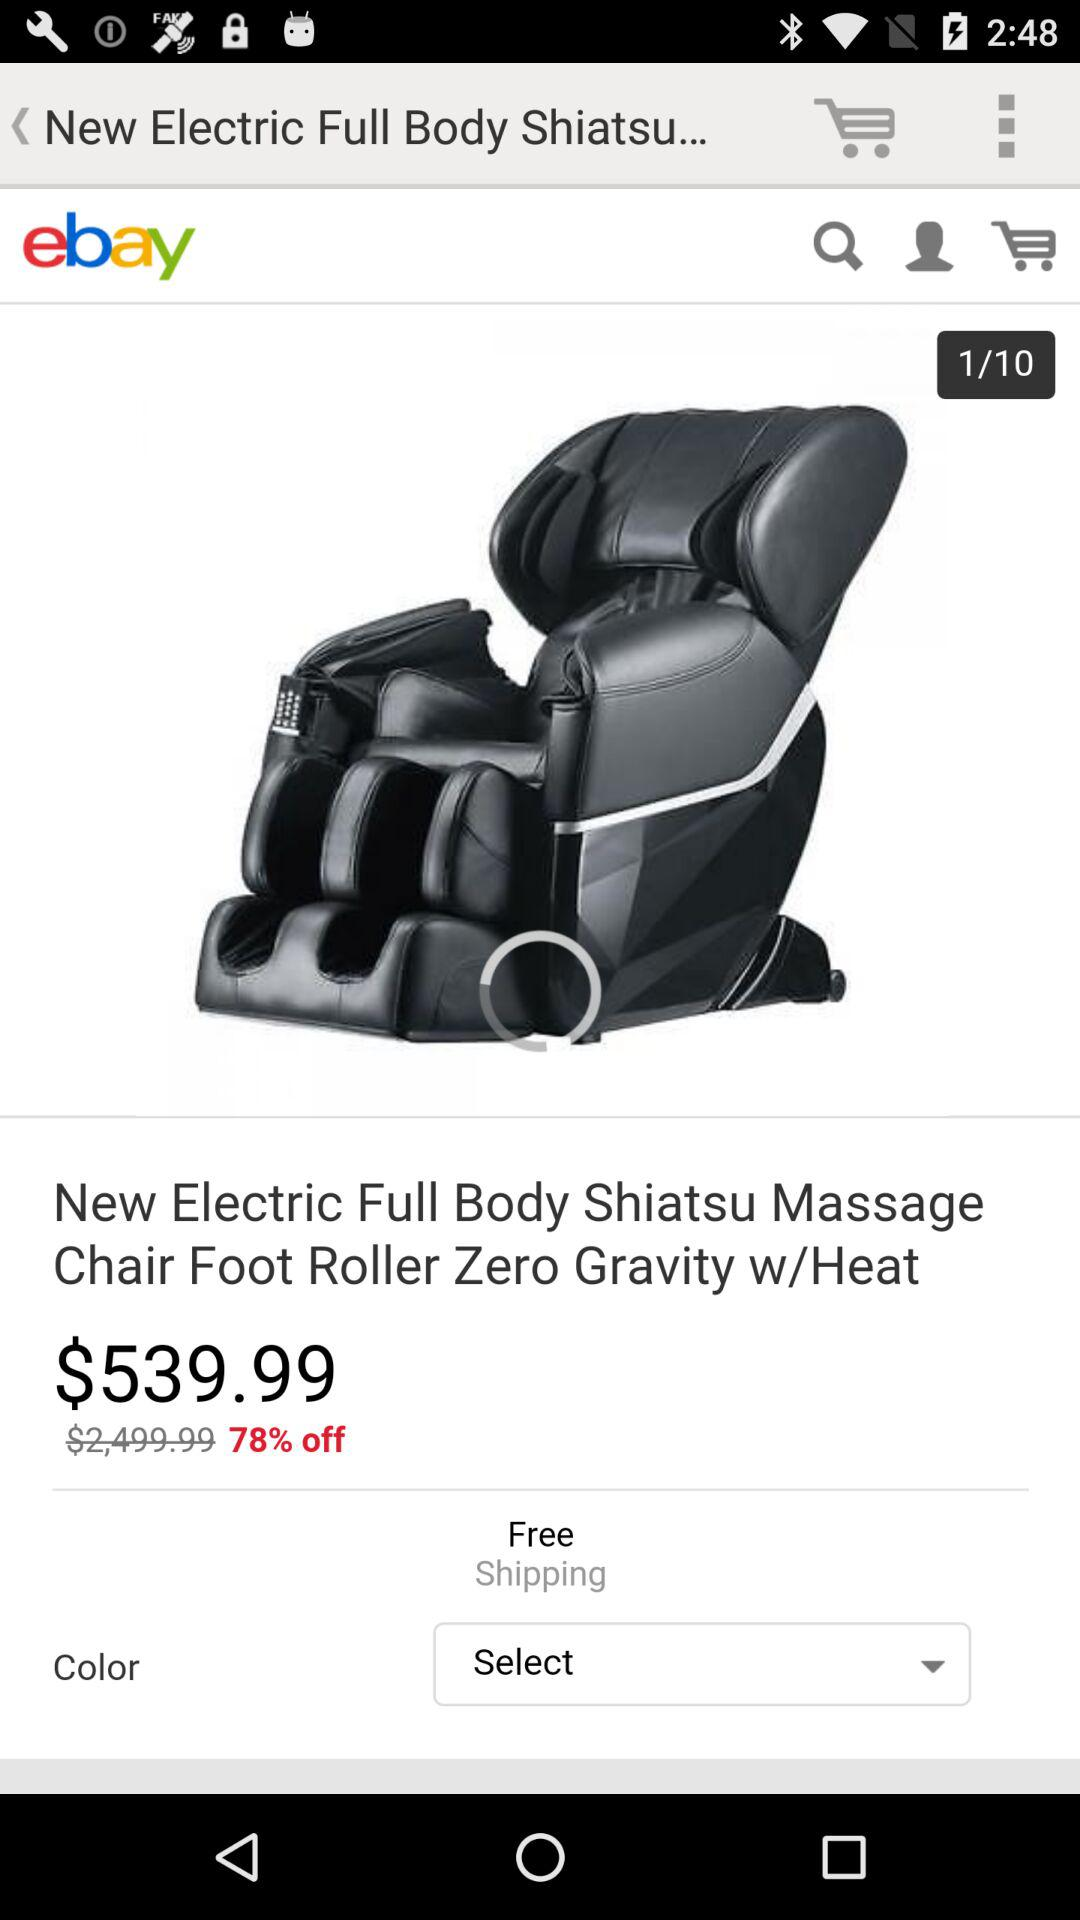How much is the discount on the product?
Answer the question using a single word or phrase. 78% 